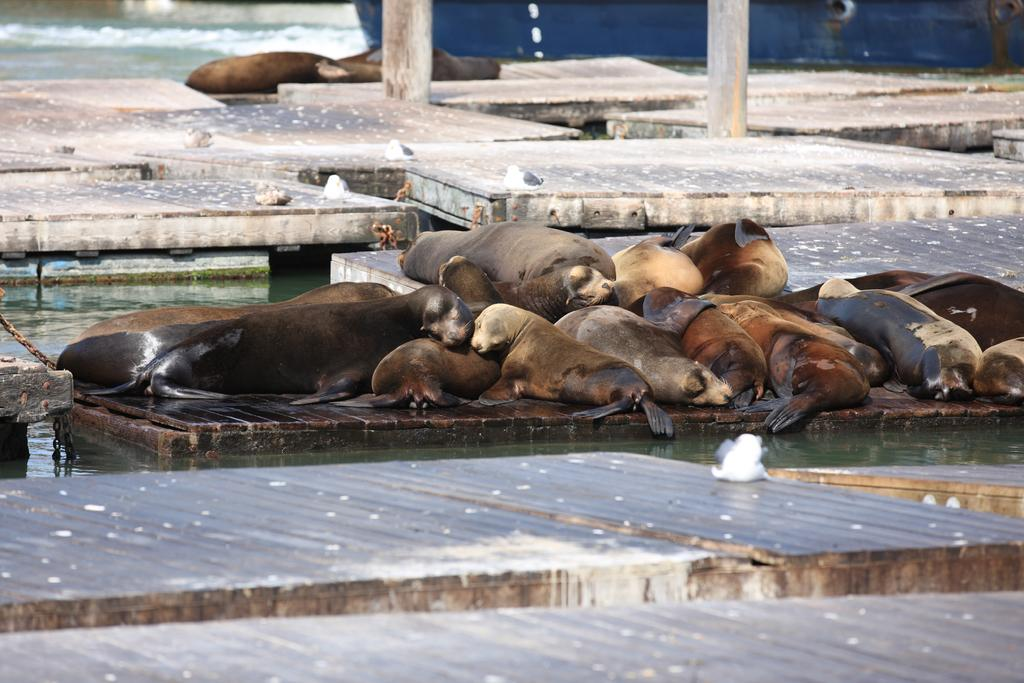What animals can be seen in the image? There are seals in the image. What is the primary element in which the seals are situated? There is water visible in the image, and the seals are in the water. What type of eggs can be seen in the image? There are no eggs present in the image; it features seals in water. How many sheep can be seen in the image? There are no sheep present in the image; it features seals in water. 